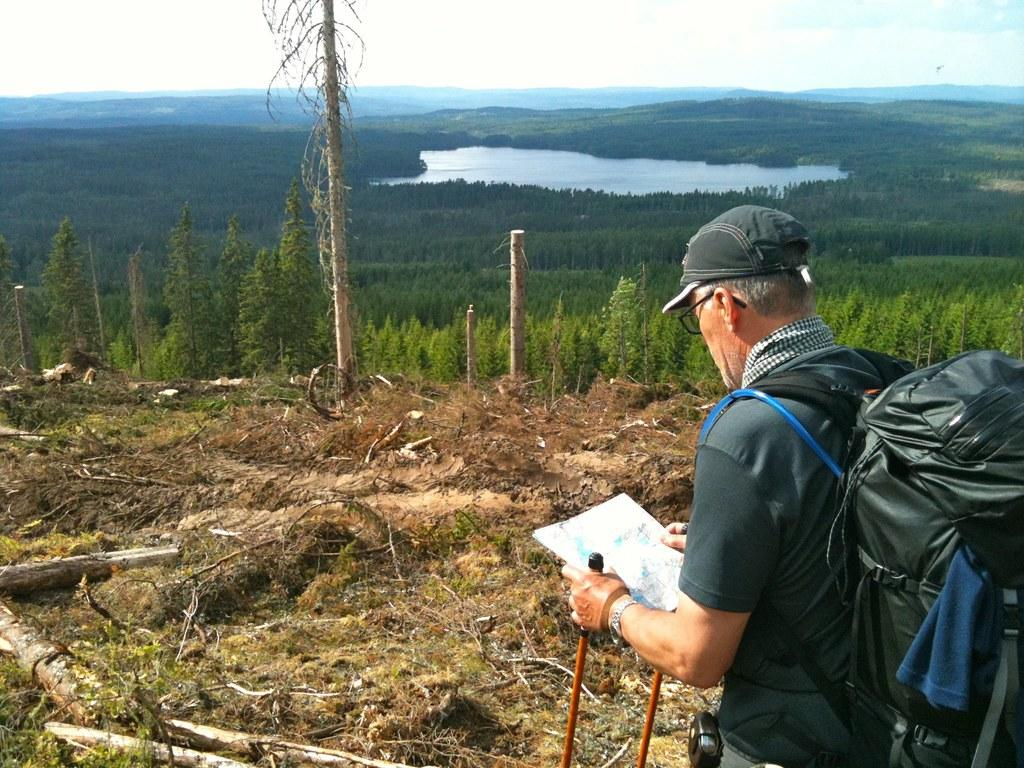What is the main subject of the image? There is a person in the image. What is the person wearing? The person is wearing a bag. What is the person holding? The person is holding a paper. What type of natural elements can be seen in the image? There are trees, water, and the sky visible in the image. What type of mine can be seen in the image? There is no mine present in the image. How hot is the water visible in the image? The temperature of the water cannot be determined from the image. 